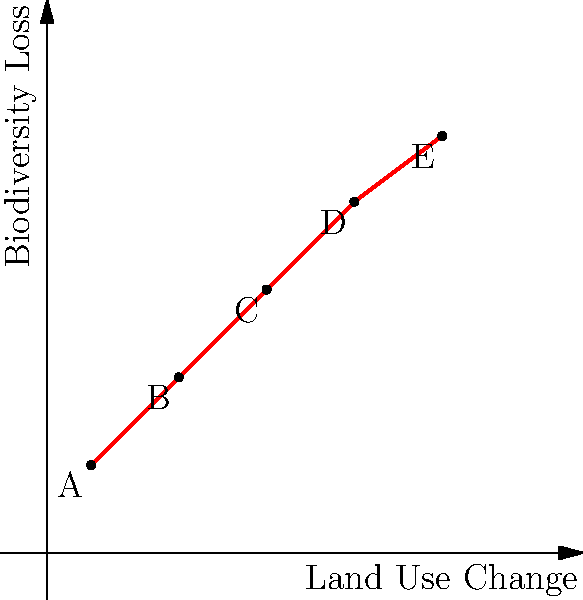Based on the scatter plot showing the relationship between land use change and biodiversity loss, what type of correlation is observed, and what ecological implication does this suggest for the research paper under review? To answer this question, we need to analyze the scatter plot step-by-step:

1. Observe the overall trend: As we move from left to right (increasing land use change), the points generally move upward (increasing biodiversity loss).

2. Assess the linearity: The points form a roughly straight line, suggesting a linear relationship.

3. Determine the direction: The line slopes upward from left to right, indicating a positive relationship.

4. Evaluate the strength: The points are close to a straight line with little scatter, suggesting a strong relationship.

5. Identify the correlation type: Based on the above observations, this is a strong positive linear correlation.

6. Ecological implication: This correlation suggests that as land use change increases, biodiversity loss also increases at a consistent rate. This implies that human activities that alter land use (e.g., deforestation, urbanization, agricultural expansion) are strongly associated with declines in biodiversity.

7. Research paper implications: The author should discuss the potential causal mechanisms behind this relationship, consider confounding variables, and explore policy implications for land use management and biodiversity conservation.
Answer: Strong positive linear correlation; suggests direct relationship between land use change and biodiversity loss. 